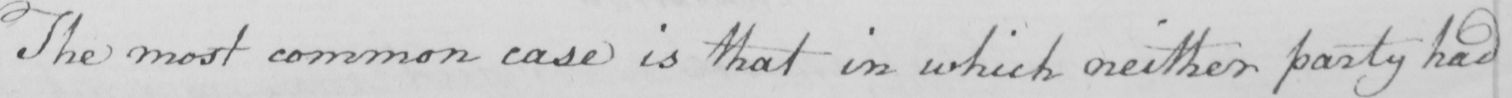Can you tell me what this handwritten text says? The most common case is that in which neither party had 